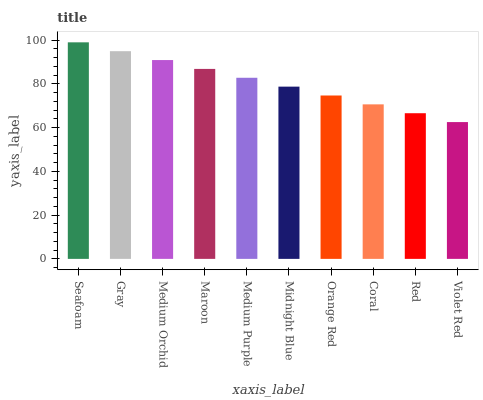Is Gray the minimum?
Answer yes or no. No. Is Gray the maximum?
Answer yes or no. No. Is Seafoam greater than Gray?
Answer yes or no. Yes. Is Gray less than Seafoam?
Answer yes or no. Yes. Is Gray greater than Seafoam?
Answer yes or no. No. Is Seafoam less than Gray?
Answer yes or no. No. Is Medium Purple the high median?
Answer yes or no. Yes. Is Midnight Blue the low median?
Answer yes or no. Yes. Is Seafoam the high median?
Answer yes or no. No. Is Gray the low median?
Answer yes or no. No. 